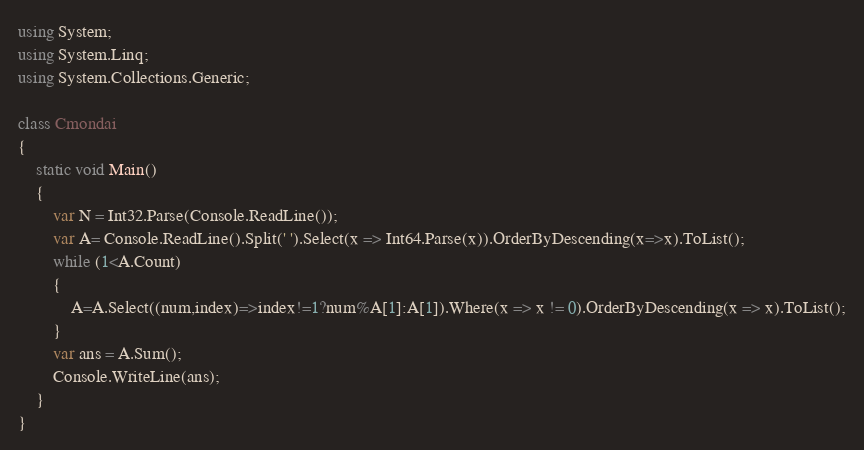Convert code to text. <code><loc_0><loc_0><loc_500><loc_500><_C#_>using System;
using System.Linq;
using System.Collections.Generic;

class Cmondai
{
    static void Main()
    {
        var N = Int32.Parse(Console.ReadLine());
        var A= Console.ReadLine().Split(' ').Select(x => Int64.Parse(x)).OrderByDescending(x=>x).ToList();
        while (1<A.Count)
        {
            A=A.Select((num,index)=>index!=1?num%A[1]:A[1]).Where(x => x != 0).OrderByDescending(x => x).ToList();
        }
        var ans = A.Sum();
        Console.WriteLine(ans);
    }
}</code> 